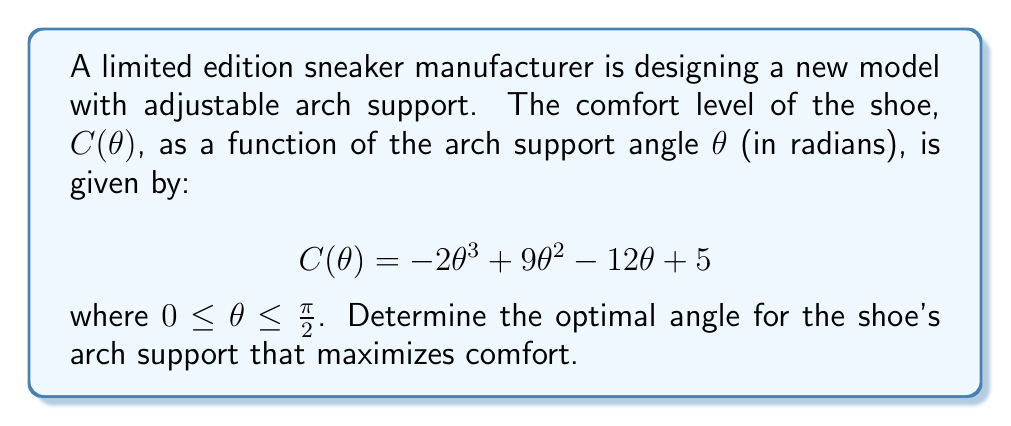Solve this math problem. To find the optimal angle that maximizes comfort, we need to find the maximum value of the function C(θ) in the given interval [0, π/2]. We can do this by finding the critical points of the function and evaluating them.

Step 1: Find the derivative of C(θ)
$$C'(\theta) = -6\theta^2 + 18\theta - 12$$

Step 2: Set the derivative equal to zero and solve for θ
$$-6\theta^2 + 18\theta - 12 = 0$$
$$-6(\theta^2 - 3\theta + 2) = 0$$
$$-6(\theta - 1)(\theta - 2) = 0$$

The solutions are θ = 1 and θ = 2.

Step 3: Check the endpoints of the interval [0, π/2]
We need to consider θ = 0 and θ = π/2 as potential maximum points.

Step 4: Evaluate C(θ) at the critical points and endpoints
C(0) = 5
C(1) = -2 + 9 - 12 + 5 = 0
C(2) = -16 + 36 - 24 + 5 = 1
C(π/2) ≈ -1.15 (using a calculator)

Step 5: Compare the values
The maximum value occurs at θ = 0, which gives C(0) = 5.

Step 6: Verify it's a maximum
We can confirm this is a maximum by checking the second derivative:
$$C''(\theta) = -12\theta + 18$$
At θ = 0, C''(0) = 18 > 0, confirming it's a local minimum.
At θ = 1, C''(1) = 6 > 0, also a local minimum.
At θ = 2, C''(2) = -6 < 0, confirming it's a local maximum.

Therefore, the global maximum in the interval [0, π/2] occurs at θ = 0.
Answer: The optimal angle for the shoe's arch support that maximizes comfort is 0 radians (or 0 degrees). 